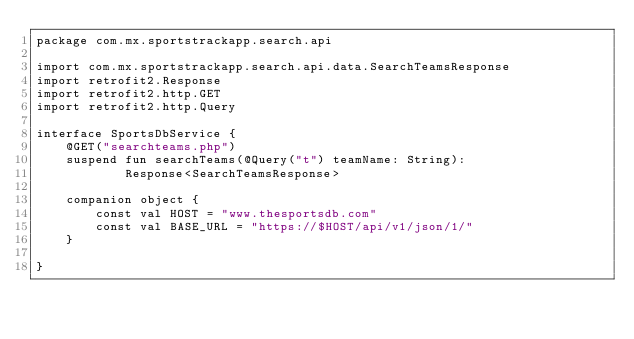<code> <loc_0><loc_0><loc_500><loc_500><_Kotlin_>package com.mx.sportstrackapp.search.api

import com.mx.sportstrackapp.search.api.data.SearchTeamsResponse
import retrofit2.Response
import retrofit2.http.GET
import retrofit2.http.Query

interface SportsDbService {
    @GET("searchteams.php")
    suspend fun searchTeams(@Query("t") teamName: String):
            Response<SearchTeamsResponse>

    companion object {
        const val HOST = "www.thesportsdb.com"
        const val BASE_URL = "https://$HOST/api/v1/json/1/"
    }

}
</code> 